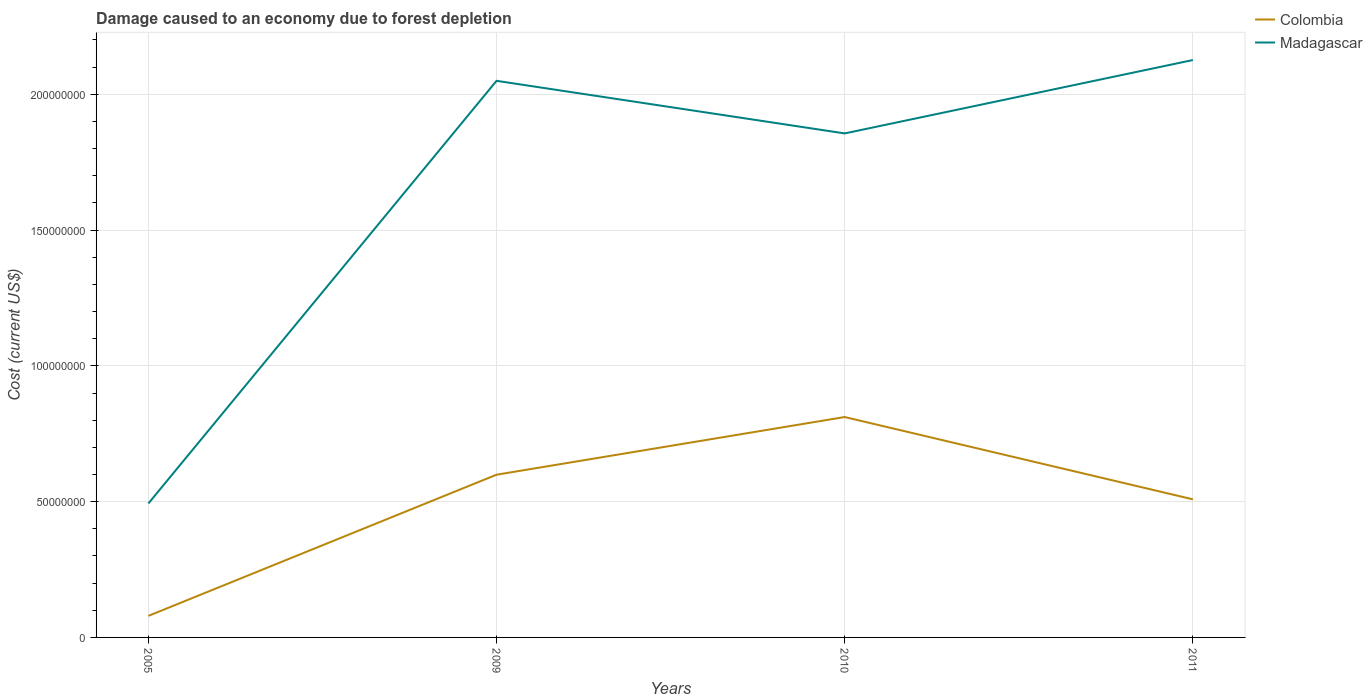How many different coloured lines are there?
Keep it short and to the point. 2. Does the line corresponding to Colombia intersect with the line corresponding to Madagascar?
Ensure brevity in your answer.  No. Is the number of lines equal to the number of legend labels?
Provide a succinct answer. Yes. Across all years, what is the maximum cost of damage caused due to forest depletion in Colombia?
Provide a succinct answer. 7.93e+06. In which year was the cost of damage caused due to forest depletion in Colombia maximum?
Make the answer very short. 2005. What is the total cost of damage caused due to forest depletion in Madagascar in the graph?
Ensure brevity in your answer.  1.94e+07. What is the difference between the highest and the second highest cost of damage caused due to forest depletion in Colombia?
Make the answer very short. 7.32e+07. What is the difference between the highest and the lowest cost of damage caused due to forest depletion in Colombia?
Offer a very short reply. 3. Are the values on the major ticks of Y-axis written in scientific E-notation?
Your answer should be very brief. No. Does the graph contain grids?
Give a very brief answer. Yes. Where does the legend appear in the graph?
Make the answer very short. Top right. How many legend labels are there?
Offer a terse response. 2. How are the legend labels stacked?
Your response must be concise. Vertical. What is the title of the graph?
Offer a terse response. Damage caused to an economy due to forest depletion. Does "Pakistan" appear as one of the legend labels in the graph?
Provide a short and direct response. No. What is the label or title of the Y-axis?
Provide a short and direct response. Cost (current US$). What is the Cost (current US$) in Colombia in 2005?
Keep it short and to the point. 7.93e+06. What is the Cost (current US$) of Madagascar in 2005?
Offer a very short reply. 4.93e+07. What is the Cost (current US$) in Colombia in 2009?
Your response must be concise. 5.99e+07. What is the Cost (current US$) of Madagascar in 2009?
Provide a short and direct response. 2.05e+08. What is the Cost (current US$) in Colombia in 2010?
Ensure brevity in your answer.  8.12e+07. What is the Cost (current US$) in Madagascar in 2010?
Keep it short and to the point. 1.86e+08. What is the Cost (current US$) of Colombia in 2011?
Your answer should be very brief. 5.09e+07. What is the Cost (current US$) in Madagascar in 2011?
Provide a succinct answer. 2.13e+08. Across all years, what is the maximum Cost (current US$) of Colombia?
Your answer should be compact. 8.12e+07. Across all years, what is the maximum Cost (current US$) in Madagascar?
Provide a short and direct response. 2.13e+08. Across all years, what is the minimum Cost (current US$) in Colombia?
Your response must be concise. 7.93e+06. Across all years, what is the minimum Cost (current US$) of Madagascar?
Provide a short and direct response. 4.93e+07. What is the total Cost (current US$) in Colombia in the graph?
Offer a very short reply. 2.00e+08. What is the total Cost (current US$) of Madagascar in the graph?
Give a very brief answer. 6.52e+08. What is the difference between the Cost (current US$) of Colombia in 2005 and that in 2009?
Your response must be concise. -5.20e+07. What is the difference between the Cost (current US$) in Madagascar in 2005 and that in 2009?
Make the answer very short. -1.56e+08. What is the difference between the Cost (current US$) of Colombia in 2005 and that in 2010?
Provide a succinct answer. -7.32e+07. What is the difference between the Cost (current US$) of Madagascar in 2005 and that in 2010?
Your answer should be very brief. -1.36e+08. What is the difference between the Cost (current US$) in Colombia in 2005 and that in 2011?
Provide a short and direct response. -4.29e+07. What is the difference between the Cost (current US$) in Madagascar in 2005 and that in 2011?
Provide a short and direct response. -1.63e+08. What is the difference between the Cost (current US$) in Colombia in 2009 and that in 2010?
Give a very brief answer. -2.12e+07. What is the difference between the Cost (current US$) of Madagascar in 2009 and that in 2010?
Keep it short and to the point. 1.94e+07. What is the difference between the Cost (current US$) in Colombia in 2009 and that in 2011?
Provide a short and direct response. 9.06e+06. What is the difference between the Cost (current US$) of Madagascar in 2009 and that in 2011?
Provide a succinct answer. -7.65e+06. What is the difference between the Cost (current US$) in Colombia in 2010 and that in 2011?
Ensure brevity in your answer.  3.03e+07. What is the difference between the Cost (current US$) in Madagascar in 2010 and that in 2011?
Provide a short and direct response. -2.70e+07. What is the difference between the Cost (current US$) of Colombia in 2005 and the Cost (current US$) of Madagascar in 2009?
Provide a succinct answer. -1.97e+08. What is the difference between the Cost (current US$) of Colombia in 2005 and the Cost (current US$) of Madagascar in 2010?
Provide a succinct answer. -1.78e+08. What is the difference between the Cost (current US$) of Colombia in 2005 and the Cost (current US$) of Madagascar in 2011?
Keep it short and to the point. -2.05e+08. What is the difference between the Cost (current US$) in Colombia in 2009 and the Cost (current US$) in Madagascar in 2010?
Give a very brief answer. -1.26e+08. What is the difference between the Cost (current US$) of Colombia in 2009 and the Cost (current US$) of Madagascar in 2011?
Your answer should be very brief. -1.53e+08. What is the difference between the Cost (current US$) in Colombia in 2010 and the Cost (current US$) in Madagascar in 2011?
Offer a very short reply. -1.31e+08. What is the average Cost (current US$) in Colombia per year?
Provide a short and direct response. 5.00e+07. What is the average Cost (current US$) in Madagascar per year?
Make the answer very short. 1.63e+08. In the year 2005, what is the difference between the Cost (current US$) in Colombia and Cost (current US$) in Madagascar?
Ensure brevity in your answer.  -4.14e+07. In the year 2009, what is the difference between the Cost (current US$) of Colombia and Cost (current US$) of Madagascar?
Your response must be concise. -1.45e+08. In the year 2010, what is the difference between the Cost (current US$) of Colombia and Cost (current US$) of Madagascar?
Keep it short and to the point. -1.04e+08. In the year 2011, what is the difference between the Cost (current US$) in Colombia and Cost (current US$) in Madagascar?
Provide a succinct answer. -1.62e+08. What is the ratio of the Cost (current US$) in Colombia in 2005 to that in 2009?
Provide a short and direct response. 0.13. What is the ratio of the Cost (current US$) of Madagascar in 2005 to that in 2009?
Your answer should be very brief. 0.24. What is the ratio of the Cost (current US$) of Colombia in 2005 to that in 2010?
Your answer should be very brief. 0.1. What is the ratio of the Cost (current US$) of Madagascar in 2005 to that in 2010?
Make the answer very short. 0.27. What is the ratio of the Cost (current US$) in Colombia in 2005 to that in 2011?
Provide a succinct answer. 0.16. What is the ratio of the Cost (current US$) of Madagascar in 2005 to that in 2011?
Your response must be concise. 0.23. What is the ratio of the Cost (current US$) in Colombia in 2009 to that in 2010?
Your answer should be compact. 0.74. What is the ratio of the Cost (current US$) in Madagascar in 2009 to that in 2010?
Ensure brevity in your answer.  1.1. What is the ratio of the Cost (current US$) of Colombia in 2009 to that in 2011?
Give a very brief answer. 1.18. What is the ratio of the Cost (current US$) of Madagascar in 2009 to that in 2011?
Your answer should be very brief. 0.96. What is the ratio of the Cost (current US$) of Colombia in 2010 to that in 2011?
Make the answer very short. 1.6. What is the ratio of the Cost (current US$) of Madagascar in 2010 to that in 2011?
Ensure brevity in your answer.  0.87. What is the difference between the highest and the second highest Cost (current US$) of Colombia?
Your answer should be very brief. 2.12e+07. What is the difference between the highest and the second highest Cost (current US$) in Madagascar?
Your answer should be compact. 7.65e+06. What is the difference between the highest and the lowest Cost (current US$) of Colombia?
Your answer should be compact. 7.32e+07. What is the difference between the highest and the lowest Cost (current US$) in Madagascar?
Your response must be concise. 1.63e+08. 